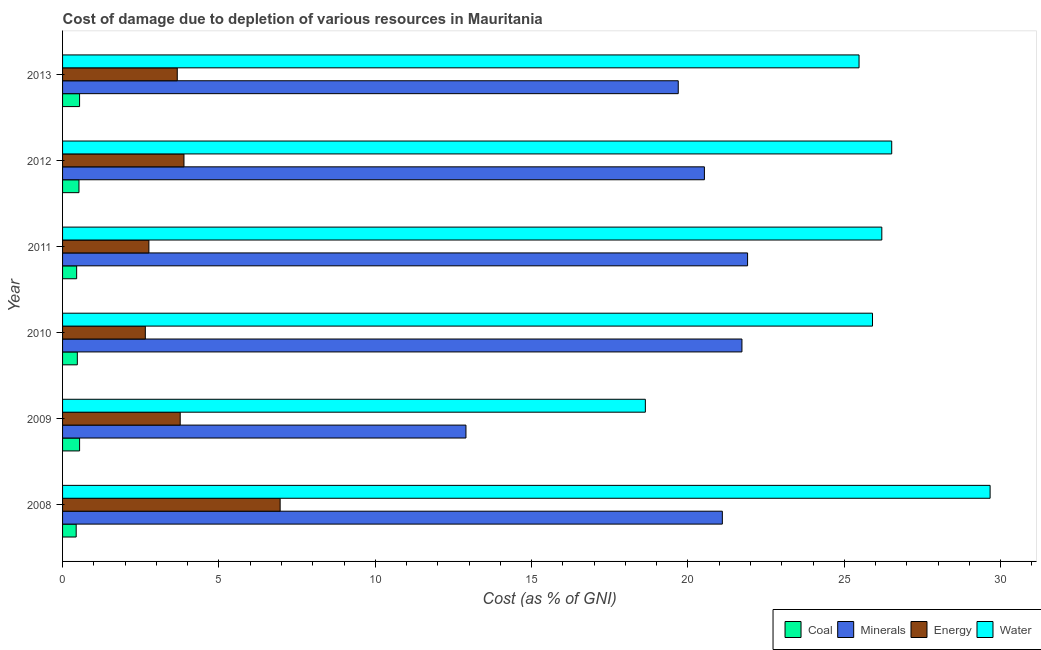How many different coloured bars are there?
Your answer should be very brief. 4. In how many cases, is the number of bars for a given year not equal to the number of legend labels?
Keep it short and to the point. 0. What is the cost of damage due to depletion of water in 2008?
Your answer should be very brief. 29.66. Across all years, what is the maximum cost of damage due to depletion of coal?
Provide a succinct answer. 0.54. Across all years, what is the minimum cost of damage due to depletion of coal?
Provide a succinct answer. 0.44. What is the total cost of damage due to depletion of coal in the graph?
Your answer should be compact. 2.97. What is the difference between the cost of damage due to depletion of water in 2008 and that in 2013?
Offer a very short reply. 4.19. What is the difference between the cost of damage due to depletion of energy in 2010 and the cost of damage due to depletion of minerals in 2011?
Offer a very short reply. -19.26. What is the average cost of damage due to depletion of water per year?
Offer a terse response. 25.4. In the year 2008, what is the difference between the cost of damage due to depletion of coal and cost of damage due to depletion of minerals?
Your answer should be very brief. -20.66. In how many years, is the cost of damage due to depletion of water greater than 12 %?
Ensure brevity in your answer.  6. What is the ratio of the cost of damage due to depletion of energy in 2009 to that in 2013?
Your answer should be compact. 1.03. Is the cost of damage due to depletion of energy in 2010 less than that in 2012?
Your answer should be compact. Yes. Is the difference between the cost of damage due to depletion of water in 2012 and 2013 greater than the difference between the cost of damage due to depletion of energy in 2012 and 2013?
Offer a terse response. Yes. What is the difference between the highest and the second highest cost of damage due to depletion of coal?
Your response must be concise. 0. What is the difference between the highest and the lowest cost of damage due to depletion of water?
Provide a short and direct response. 11.02. In how many years, is the cost of damage due to depletion of water greater than the average cost of damage due to depletion of water taken over all years?
Your answer should be very brief. 5. What does the 1st bar from the top in 2012 represents?
Your response must be concise. Water. What does the 1st bar from the bottom in 2013 represents?
Give a very brief answer. Coal. Are all the bars in the graph horizontal?
Provide a short and direct response. Yes. How many years are there in the graph?
Your answer should be very brief. 6. What is the difference between two consecutive major ticks on the X-axis?
Offer a very short reply. 5. Does the graph contain any zero values?
Your response must be concise. No. Where does the legend appear in the graph?
Your answer should be very brief. Bottom right. How many legend labels are there?
Your response must be concise. 4. What is the title of the graph?
Your answer should be very brief. Cost of damage due to depletion of various resources in Mauritania . Does "Social Assistance" appear as one of the legend labels in the graph?
Keep it short and to the point. No. What is the label or title of the X-axis?
Ensure brevity in your answer.  Cost (as % of GNI). What is the Cost (as % of GNI) of Coal in 2008?
Your answer should be compact. 0.44. What is the Cost (as % of GNI) of Minerals in 2008?
Your answer should be very brief. 21.1. What is the Cost (as % of GNI) of Energy in 2008?
Offer a terse response. 6.96. What is the Cost (as % of GNI) of Water in 2008?
Provide a succinct answer. 29.66. What is the Cost (as % of GNI) in Coal in 2009?
Ensure brevity in your answer.  0.54. What is the Cost (as % of GNI) of Minerals in 2009?
Your response must be concise. 12.9. What is the Cost (as % of GNI) in Energy in 2009?
Offer a terse response. 3.76. What is the Cost (as % of GNI) of Water in 2009?
Keep it short and to the point. 18.64. What is the Cost (as % of GNI) of Coal in 2010?
Provide a short and direct response. 0.47. What is the Cost (as % of GNI) of Minerals in 2010?
Give a very brief answer. 21.73. What is the Cost (as % of GNI) in Energy in 2010?
Give a very brief answer. 2.65. What is the Cost (as % of GNI) of Water in 2010?
Your answer should be compact. 25.9. What is the Cost (as % of GNI) of Coal in 2011?
Provide a succinct answer. 0.45. What is the Cost (as % of GNI) of Minerals in 2011?
Make the answer very short. 21.91. What is the Cost (as % of GNI) of Energy in 2011?
Keep it short and to the point. 2.76. What is the Cost (as % of GNI) in Water in 2011?
Keep it short and to the point. 26.2. What is the Cost (as % of GNI) in Coal in 2012?
Your response must be concise. 0.52. What is the Cost (as % of GNI) of Minerals in 2012?
Offer a terse response. 20.53. What is the Cost (as % of GNI) of Energy in 2012?
Give a very brief answer. 3.88. What is the Cost (as % of GNI) in Water in 2012?
Your response must be concise. 26.52. What is the Cost (as % of GNI) in Coal in 2013?
Your answer should be very brief. 0.54. What is the Cost (as % of GNI) of Minerals in 2013?
Keep it short and to the point. 19.69. What is the Cost (as % of GNI) in Energy in 2013?
Offer a very short reply. 3.67. What is the Cost (as % of GNI) in Water in 2013?
Give a very brief answer. 25.47. Across all years, what is the maximum Cost (as % of GNI) in Coal?
Your response must be concise. 0.54. Across all years, what is the maximum Cost (as % of GNI) of Minerals?
Your answer should be compact. 21.91. Across all years, what is the maximum Cost (as % of GNI) in Energy?
Provide a succinct answer. 6.96. Across all years, what is the maximum Cost (as % of GNI) in Water?
Offer a terse response. 29.66. Across all years, what is the minimum Cost (as % of GNI) of Coal?
Your response must be concise. 0.44. Across all years, what is the minimum Cost (as % of GNI) in Minerals?
Provide a succinct answer. 12.9. Across all years, what is the minimum Cost (as % of GNI) of Energy?
Your answer should be very brief. 2.65. Across all years, what is the minimum Cost (as % of GNI) in Water?
Give a very brief answer. 18.64. What is the total Cost (as % of GNI) in Coal in the graph?
Offer a very short reply. 2.97. What is the total Cost (as % of GNI) of Minerals in the graph?
Ensure brevity in your answer.  117.84. What is the total Cost (as % of GNI) in Energy in the graph?
Give a very brief answer. 23.68. What is the total Cost (as % of GNI) in Water in the graph?
Offer a terse response. 152.38. What is the difference between the Cost (as % of GNI) in Coal in 2008 and that in 2009?
Make the answer very short. -0.11. What is the difference between the Cost (as % of GNI) in Minerals in 2008 and that in 2009?
Give a very brief answer. 8.2. What is the difference between the Cost (as % of GNI) in Energy in 2008 and that in 2009?
Give a very brief answer. 3.2. What is the difference between the Cost (as % of GNI) of Water in 2008 and that in 2009?
Your response must be concise. 11.02. What is the difference between the Cost (as % of GNI) of Coal in 2008 and that in 2010?
Keep it short and to the point. -0.04. What is the difference between the Cost (as % of GNI) of Minerals in 2008 and that in 2010?
Give a very brief answer. -0.63. What is the difference between the Cost (as % of GNI) in Energy in 2008 and that in 2010?
Your answer should be compact. 4.31. What is the difference between the Cost (as % of GNI) of Water in 2008 and that in 2010?
Your response must be concise. 3.76. What is the difference between the Cost (as % of GNI) of Coal in 2008 and that in 2011?
Keep it short and to the point. -0.02. What is the difference between the Cost (as % of GNI) in Minerals in 2008 and that in 2011?
Your answer should be very brief. -0.81. What is the difference between the Cost (as % of GNI) of Energy in 2008 and that in 2011?
Offer a terse response. 4.2. What is the difference between the Cost (as % of GNI) in Water in 2008 and that in 2011?
Give a very brief answer. 3.46. What is the difference between the Cost (as % of GNI) in Coal in 2008 and that in 2012?
Your answer should be very brief. -0.09. What is the difference between the Cost (as % of GNI) of Minerals in 2008 and that in 2012?
Your answer should be very brief. 0.57. What is the difference between the Cost (as % of GNI) in Energy in 2008 and that in 2012?
Your answer should be very brief. 3.08. What is the difference between the Cost (as % of GNI) of Water in 2008 and that in 2012?
Give a very brief answer. 3.15. What is the difference between the Cost (as % of GNI) in Coal in 2008 and that in 2013?
Offer a very short reply. -0.11. What is the difference between the Cost (as % of GNI) of Minerals in 2008 and that in 2013?
Make the answer very short. 1.41. What is the difference between the Cost (as % of GNI) in Energy in 2008 and that in 2013?
Provide a succinct answer. 3.29. What is the difference between the Cost (as % of GNI) in Water in 2008 and that in 2013?
Provide a short and direct response. 4.19. What is the difference between the Cost (as % of GNI) in Coal in 2009 and that in 2010?
Ensure brevity in your answer.  0.07. What is the difference between the Cost (as % of GNI) in Minerals in 2009 and that in 2010?
Provide a short and direct response. -8.83. What is the difference between the Cost (as % of GNI) in Energy in 2009 and that in 2010?
Make the answer very short. 1.12. What is the difference between the Cost (as % of GNI) of Water in 2009 and that in 2010?
Offer a terse response. -7.26. What is the difference between the Cost (as % of GNI) of Coal in 2009 and that in 2011?
Your response must be concise. 0.09. What is the difference between the Cost (as % of GNI) of Minerals in 2009 and that in 2011?
Make the answer very short. -9.01. What is the difference between the Cost (as % of GNI) of Water in 2009 and that in 2011?
Offer a terse response. -7.56. What is the difference between the Cost (as % of GNI) in Coal in 2009 and that in 2012?
Provide a succinct answer. 0.02. What is the difference between the Cost (as % of GNI) of Minerals in 2009 and that in 2012?
Provide a short and direct response. -7.63. What is the difference between the Cost (as % of GNI) of Energy in 2009 and that in 2012?
Your answer should be very brief. -0.12. What is the difference between the Cost (as % of GNI) in Water in 2009 and that in 2012?
Make the answer very short. -7.88. What is the difference between the Cost (as % of GNI) of Coal in 2009 and that in 2013?
Ensure brevity in your answer.  0. What is the difference between the Cost (as % of GNI) in Minerals in 2009 and that in 2013?
Offer a terse response. -6.79. What is the difference between the Cost (as % of GNI) of Energy in 2009 and that in 2013?
Give a very brief answer. 0.09. What is the difference between the Cost (as % of GNI) of Water in 2009 and that in 2013?
Ensure brevity in your answer.  -6.83. What is the difference between the Cost (as % of GNI) in Coal in 2010 and that in 2011?
Your answer should be compact. 0.02. What is the difference between the Cost (as % of GNI) in Minerals in 2010 and that in 2011?
Your response must be concise. -0.18. What is the difference between the Cost (as % of GNI) of Energy in 2010 and that in 2011?
Make the answer very short. -0.11. What is the difference between the Cost (as % of GNI) in Water in 2010 and that in 2011?
Your response must be concise. -0.3. What is the difference between the Cost (as % of GNI) in Coal in 2010 and that in 2012?
Ensure brevity in your answer.  -0.05. What is the difference between the Cost (as % of GNI) of Energy in 2010 and that in 2012?
Keep it short and to the point. -1.24. What is the difference between the Cost (as % of GNI) of Water in 2010 and that in 2012?
Make the answer very short. -0.61. What is the difference between the Cost (as % of GNI) in Coal in 2010 and that in 2013?
Your answer should be very brief. -0.07. What is the difference between the Cost (as % of GNI) in Minerals in 2010 and that in 2013?
Make the answer very short. 2.04. What is the difference between the Cost (as % of GNI) of Energy in 2010 and that in 2013?
Offer a terse response. -1.02. What is the difference between the Cost (as % of GNI) in Water in 2010 and that in 2013?
Offer a terse response. 0.43. What is the difference between the Cost (as % of GNI) of Coal in 2011 and that in 2012?
Offer a terse response. -0.07. What is the difference between the Cost (as % of GNI) in Minerals in 2011 and that in 2012?
Make the answer very short. 1.38. What is the difference between the Cost (as % of GNI) in Energy in 2011 and that in 2012?
Your answer should be very brief. -1.12. What is the difference between the Cost (as % of GNI) in Water in 2011 and that in 2012?
Offer a very short reply. -0.32. What is the difference between the Cost (as % of GNI) in Coal in 2011 and that in 2013?
Your answer should be very brief. -0.09. What is the difference between the Cost (as % of GNI) in Minerals in 2011 and that in 2013?
Offer a very short reply. 2.22. What is the difference between the Cost (as % of GNI) in Energy in 2011 and that in 2013?
Give a very brief answer. -0.91. What is the difference between the Cost (as % of GNI) in Water in 2011 and that in 2013?
Provide a succinct answer. 0.73. What is the difference between the Cost (as % of GNI) of Coal in 2012 and that in 2013?
Your answer should be very brief. -0.02. What is the difference between the Cost (as % of GNI) of Minerals in 2012 and that in 2013?
Your answer should be very brief. 0.84. What is the difference between the Cost (as % of GNI) in Energy in 2012 and that in 2013?
Make the answer very short. 0.21. What is the difference between the Cost (as % of GNI) of Water in 2012 and that in 2013?
Ensure brevity in your answer.  1.04. What is the difference between the Cost (as % of GNI) in Coal in 2008 and the Cost (as % of GNI) in Minerals in 2009?
Keep it short and to the point. -12.46. What is the difference between the Cost (as % of GNI) in Coal in 2008 and the Cost (as % of GNI) in Energy in 2009?
Your answer should be compact. -3.33. What is the difference between the Cost (as % of GNI) of Coal in 2008 and the Cost (as % of GNI) of Water in 2009?
Provide a succinct answer. -18.2. What is the difference between the Cost (as % of GNI) in Minerals in 2008 and the Cost (as % of GNI) in Energy in 2009?
Provide a succinct answer. 17.34. What is the difference between the Cost (as % of GNI) in Minerals in 2008 and the Cost (as % of GNI) in Water in 2009?
Your answer should be compact. 2.46. What is the difference between the Cost (as % of GNI) of Energy in 2008 and the Cost (as % of GNI) of Water in 2009?
Your answer should be very brief. -11.68. What is the difference between the Cost (as % of GNI) of Coal in 2008 and the Cost (as % of GNI) of Minerals in 2010?
Your response must be concise. -21.29. What is the difference between the Cost (as % of GNI) of Coal in 2008 and the Cost (as % of GNI) of Energy in 2010?
Give a very brief answer. -2.21. What is the difference between the Cost (as % of GNI) of Coal in 2008 and the Cost (as % of GNI) of Water in 2010?
Provide a succinct answer. -25.47. What is the difference between the Cost (as % of GNI) in Minerals in 2008 and the Cost (as % of GNI) in Energy in 2010?
Keep it short and to the point. 18.45. What is the difference between the Cost (as % of GNI) of Minerals in 2008 and the Cost (as % of GNI) of Water in 2010?
Ensure brevity in your answer.  -4.8. What is the difference between the Cost (as % of GNI) in Energy in 2008 and the Cost (as % of GNI) in Water in 2010?
Offer a terse response. -18.94. What is the difference between the Cost (as % of GNI) of Coal in 2008 and the Cost (as % of GNI) of Minerals in 2011?
Offer a terse response. -21.47. What is the difference between the Cost (as % of GNI) in Coal in 2008 and the Cost (as % of GNI) in Energy in 2011?
Provide a succinct answer. -2.33. What is the difference between the Cost (as % of GNI) of Coal in 2008 and the Cost (as % of GNI) of Water in 2011?
Provide a short and direct response. -25.76. What is the difference between the Cost (as % of GNI) in Minerals in 2008 and the Cost (as % of GNI) in Energy in 2011?
Provide a short and direct response. 18.34. What is the difference between the Cost (as % of GNI) of Minerals in 2008 and the Cost (as % of GNI) of Water in 2011?
Offer a terse response. -5.1. What is the difference between the Cost (as % of GNI) in Energy in 2008 and the Cost (as % of GNI) in Water in 2011?
Keep it short and to the point. -19.24. What is the difference between the Cost (as % of GNI) of Coal in 2008 and the Cost (as % of GNI) of Minerals in 2012?
Provide a succinct answer. -20.09. What is the difference between the Cost (as % of GNI) of Coal in 2008 and the Cost (as % of GNI) of Energy in 2012?
Keep it short and to the point. -3.45. What is the difference between the Cost (as % of GNI) in Coal in 2008 and the Cost (as % of GNI) in Water in 2012?
Make the answer very short. -26.08. What is the difference between the Cost (as % of GNI) in Minerals in 2008 and the Cost (as % of GNI) in Energy in 2012?
Your answer should be very brief. 17.22. What is the difference between the Cost (as % of GNI) of Minerals in 2008 and the Cost (as % of GNI) of Water in 2012?
Make the answer very short. -5.42. What is the difference between the Cost (as % of GNI) in Energy in 2008 and the Cost (as % of GNI) in Water in 2012?
Give a very brief answer. -19.56. What is the difference between the Cost (as % of GNI) in Coal in 2008 and the Cost (as % of GNI) in Minerals in 2013?
Your response must be concise. -19.25. What is the difference between the Cost (as % of GNI) in Coal in 2008 and the Cost (as % of GNI) in Energy in 2013?
Provide a short and direct response. -3.23. What is the difference between the Cost (as % of GNI) in Coal in 2008 and the Cost (as % of GNI) in Water in 2013?
Keep it short and to the point. -25.03. What is the difference between the Cost (as % of GNI) in Minerals in 2008 and the Cost (as % of GNI) in Energy in 2013?
Your answer should be compact. 17.43. What is the difference between the Cost (as % of GNI) in Minerals in 2008 and the Cost (as % of GNI) in Water in 2013?
Provide a succinct answer. -4.37. What is the difference between the Cost (as % of GNI) of Energy in 2008 and the Cost (as % of GNI) of Water in 2013?
Keep it short and to the point. -18.51. What is the difference between the Cost (as % of GNI) of Coal in 2009 and the Cost (as % of GNI) of Minerals in 2010?
Keep it short and to the point. -21.18. What is the difference between the Cost (as % of GNI) in Coal in 2009 and the Cost (as % of GNI) in Energy in 2010?
Your answer should be very brief. -2.1. What is the difference between the Cost (as % of GNI) in Coal in 2009 and the Cost (as % of GNI) in Water in 2010?
Offer a terse response. -25.36. What is the difference between the Cost (as % of GNI) of Minerals in 2009 and the Cost (as % of GNI) of Energy in 2010?
Ensure brevity in your answer.  10.25. What is the difference between the Cost (as % of GNI) in Minerals in 2009 and the Cost (as % of GNI) in Water in 2010?
Offer a terse response. -13. What is the difference between the Cost (as % of GNI) in Energy in 2009 and the Cost (as % of GNI) in Water in 2010?
Your response must be concise. -22.14. What is the difference between the Cost (as % of GNI) in Coal in 2009 and the Cost (as % of GNI) in Minerals in 2011?
Offer a very short reply. -21.36. What is the difference between the Cost (as % of GNI) of Coal in 2009 and the Cost (as % of GNI) of Energy in 2011?
Provide a short and direct response. -2.22. What is the difference between the Cost (as % of GNI) in Coal in 2009 and the Cost (as % of GNI) in Water in 2011?
Make the answer very short. -25.65. What is the difference between the Cost (as % of GNI) in Minerals in 2009 and the Cost (as % of GNI) in Energy in 2011?
Your response must be concise. 10.14. What is the difference between the Cost (as % of GNI) of Minerals in 2009 and the Cost (as % of GNI) of Water in 2011?
Ensure brevity in your answer.  -13.3. What is the difference between the Cost (as % of GNI) of Energy in 2009 and the Cost (as % of GNI) of Water in 2011?
Ensure brevity in your answer.  -22.44. What is the difference between the Cost (as % of GNI) in Coal in 2009 and the Cost (as % of GNI) in Minerals in 2012?
Give a very brief answer. -19.98. What is the difference between the Cost (as % of GNI) of Coal in 2009 and the Cost (as % of GNI) of Energy in 2012?
Your response must be concise. -3.34. What is the difference between the Cost (as % of GNI) of Coal in 2009 and the Cost (as % of GNI) of Water in 2012?
Provide a succinct answer. -25.97. What is the difference between the Cost (as % of GNI) of Minerals in 2009 and the Cost (as % of GNI) of Energy in 2012?
Offer a very short reply. 9.02. What is the difference between the Cost (as % of GNI) of Minerals in 2009 and the Cost (as % of GNI) of Water in 2012?
Your response must be concise. -13.62. What is the difference between the Cost (as % of GNI) in Energy in 2009 and the Cost (as % of GNI) in Water in 2012?
Provide a succinct answer. -22.75. What is the difference between the Cost (as % of GNI) of Coal in 2009 and the Cost (as % of GNI) of Minerals in 2013?
Offer a terse response. -19.14. What is the difference between the Cost (as % of GNI) of Coal in 2009 and the Cost (as % of GNI) of Energy in 2013?
Your answer should be compact. -3.12. What is the difference between the Cost (as % of GNI) in Coal in 2009 and the Cost (as % of GNI) in Water in 2013?
Keep it short and to the point. -24.93. What is the difference between the Cost (as % of GNI) in Minerals in 2009 and the Cost (as % of GNI) in Energy in 2013?
Give a very brief answer. 9.23. What is the difference between the Cost (as % of GNI) in Minerals in 2009 and the Cost (as % of GNI) in Water in 2013?
Provide a short and direct response. -12.57. What is the difference between the Cost (as % of GNI) in Energy in 2009 and the Cost (as % of GNI) in Water in 2013?
Your answer should be very brief. -21.71. What is the difference between the Cost (as % of GNI) of Coal in 2010 and the Cost (as % of GNI) of Minerals in 2011?
Provide a succinct answer. -21.43. What is the difference between the Cost (as % of GNI) in Coal in 2010 and the Cost (as % of GNI) in Energy in 2011?
Your response must be concise. -2.29. What is the difference between the Cost (as % of GNI) of Coal in 2010 and the Cost (as % of GNI) of Water in 2011?
Your answer should be compact. -25.73. What is the difference between the Cost (as % of GNI) of Minerals in 2010 and the Cost (as % of GNI) of Energy in 2011?
Your response must be concise. 18.96. What is the difference between the Cost (as % of GNI) of Minerals in 2010 and the Cost (as % of GNI) of Water in 2011?
Your answer should be compact. -4.47. What is the difference between the Cost (as % of GNI) of Energy in 2010 and the Cost (as % of GNI) of Water in 2011?
Your response must be concise. -23.55. What is the difference between the Cost (as % of GNI) in Coal in 2010 and the Cost (as % of GNI) in Minerals in 2012?
Offer a very short reply. -20.05. What is the difference between the Cost (as % of GNI) in Coal in 2010 and the Cost (as % of GNI) in Energy in 2012?
Give a very brief answer. -3.41. What is the difference between the Cost (as % of GNI) in Coal in 2010 and the Cost (as % of GNI) in Water in 2012?
Keep it short and to the point. -26.04. What is the difference between the Cost (as % of GNI) in Minerals in 2010 and the Cost (as % of GNI) in Energy in 2012?
Provide a short and direct response. 17.84. What is the difference between the Cost (as % of GNI) of Minerals in 2010 and the Cost (as % of GNI) of Water in 2012?
Your response must be concise. -4.79. What is the difference between the Cost (as % of GNI) in Energy in 2010 and the Cost (as % of GNI) in Water in 2012?
Ensure brevity in your answer.  -23.87. What is the difference between the Cost (as % of GNI) in Coal in 2010 and the Cost (as % of GNI) in Minerals in 2013?
Give a very brief answer. -19.22. What is the difference between the Cost (as % of GNI) in Coal in 2010 and the Cost (as % of GNI) in Energy in 2013?
Your response must be concise. -3.2. What is the difference between the Cost (as % of GNI) of Coal in 2010 and the Cost (as % of GNI) of Water in 2013?
Provide a succinct answer. -25. What is the difference between the Cost (as % of GNI) in Minerals in 2010 and the Cost (as % of GNI) in Energy in 2013?
Provide a short and direct response. 18.06. What is the difference between the Cost (as % of GNI) in Minerals in 2010 and the Cost (as % of GNI) in Water in 2013?
Provide a succinct answer. -3.75. What is the difference between the Cost (as % of GNI) in Energy in 2010 and the Cost (as % of GNI) in Water in 2013?
Offer a terse response. -22.82. What is the difference between the Cost (as % of GNI) in Coal in 2011 and the Cost (as % of GNI) in Minerals in 2012?
Provide a succinct answer. -20.07. What is the difference between the Cost (as % of GNI) of Coal in 2011 and the Cost (as % of GNI) of Energy in 2012?
Ensure brevity in your answer.  -3.43. What is the difference between the Cost (as % of GNI) in Coal in 2011 and the Cost (as % of GNI) in Water in 2012?
Provide a succinct answer. -26.06. What is the difference between the Cost (as % of GNI) of Minerals in 2011 and the Cost (as % of GNI) of Energy in 2012?
Ensure brevity in your answer.  18.02. What is the difference between the Cost (as % of GNI) of Minerals in 2011 and the Cost (as % of GNI) of Water in 2012?
Provide a short and direct response. -4.61. What is the difference between the Cost (as % of GNI) in Energy in 2011 and the Cost (as % of GNI) in Water in 2012?
Provide a short and direct response. -23.75. What is the difference between the Cost (as % of GNI) of Coal in 2011 and the Cost (as % of GNI) of Minerals in 2013?
Provide a succinct answer. -19.24. What is the difference between the Cost (as % of GNI) in Coal in 2011 and the Cost (as % of GNI) in Energy in 2013?
Your answer should be very brief. -3.22. What is the difference between the Cost (as % of GNI) in Coal in 2011 and the Cost (as % of GNI) in Water in 2013?
Offer a very short reply. -25.02. What is the difference between the Cost (as % of GNI) of Minerals in 2011 and the Cost (as % of GNI) of Energy in 2013?
Your answer should be very brief. 18.24. What is the difference between the Cost (as % of GNI) of Minerals in 2011 and the Cost (as % of GNI) of Water in 2013?
Keep it short and to the point. -3.56. What is the difference between the Cost (as % of GNI) of Energy in 2011 and the Cost (as % of GNI) of Water in 2013?
Provide a short and direct response. -22.71. What is the difference between the Cost (as % of GNI) in Coal in 2012 and the Cost (as % of GNI) in Minerals in 2013?
Your answer should be very brief. -19.16. What is the difference between the Cost (as % of GNI) of Coal in 2012 and the Cost (as % of GNI) of Energy in 2013?
Ensure brevity in your answer.  -3.14. What is the difference between the Cost (as % of GNI) in Coal in 2012 and the Cost (as % of GNI) in Water in 2013?
Make the answer very short. -24.95. What is the difference between the Cost (as % of GNI) of Minerals in 2012 and the Cost (as % of GNI) of Energy in 2013?
Provide a short and direct response. 16.86. What is the difference between the Cost (as % of GNI) of Minerals in 2012 and the Cost (as % of GNI) of Water in 2013?
Provide a succinct answer. -4.95. What is the difference between the Cost (as % of GNI) of Energy in 2012 and the Cost (as % of GNI) of Water in 2013?
Provide a short and direct response. -21.59. What is the average Cost (as % of GNI) of Coal per year?
Ensure brevity in your answer.  0.5. What is the average Cost (as % of GNI) of Minerals per year?
Provide a succinct answer. 19.64. What is the average Cost (as % of GNI) of Energy per year?
Keep it short and to the point. 3.95. What is the average Cost (as % of GNI) in Water per year?
Your answer should be very brief. 25.4. In the year 2008, what is the difference between the Cost (as % of GNI) of Coal and Cost (as % of GNI) of Minerals?
Provide a short and direct response. -20.66. In the year 2008, what is the difference between the Cost (as % of GNI) in Coal and Cost (as % of GNI) in Energy?
Provide a short and direct response. -6.52. In the year 2008, what is the difference between the Cost (as % of GNI) of Coal and Cost (as % of GNI) of Water?
Your response must be concise. -29.23. In the year 2008, what is the difference between the Cost (as % of GNI) in Minerals and Cost (as % of GNI) in Energy?
Offer a terse response. 14.14. In the year 2008, what is the difference between the Cost (as % of GNI) of Minerals and Cost (as % of GNI) of Water?
Provide a short and direct response. -8.56. In the year 2008, what is the difference between the Cost (as % of GNI) of Energy and Cost (as % of GNI) of Water?
Offer a very short reply. -22.7. In the year 2009, what is the difference between the Cost (as % of GNI) of Coal and Cost (as % of GNI) of Minerals?
Ensure brevity in your answer.  -12.36. In the year 2009, what is the difference between the Cost (as % of GNI) in Coal and Cost (as % of GNI) in Energy?
Offer a very short reply. -3.22. In the year 2009, what is the difference between the Cost (as % of GNI) of Coal and Cost (as % of GNI) of Water?
Keep it short and to the point. -18.09. In the year 2009, what is the difference between the Cost (as % of GNI) in Minerals and Cost (as % of GNI) in Energy?
Your answer should be compact. 9.14. In the year 2009, what is the difference between the Cost (as % of GNI) in Minerals and Cost (as % of GNI) in Water?
Your answer should be very brief. -5.74. In the year 2009, what is the difference between the Cost (as % of GNI) in Energy and Cost (as % of GNI) in Water?
Offer a terse response. -14.88. In the year 2010, what is the difference between the Cost (as % of GNI) in Coal and Cost (as % of GNI) in Minerals?
Offer a very short reply. -21.25. In the year 2010, what is the difference between the Cost (as % of GNI) in Coal and Cost (as % of GNI) in Energy?
Your response must be concise. -2.17. In the year 2010, what is the difference between the Cost (as % of GNI) of Coal and Cost (as % of GNI) of Water?
Your answer should be compact. -25.43. In the year 2010, what is the difference between the Cost (as % of GNI) of Minerals and Cost (as % of GNI) of Energy?
Your answer should be compact. 19.08. In the year 2010, what is the difference between the Cost (as % of GNI) in Minerals and Cost (as % of GNI) in Water?
Give a very brief answer. -4.18. In the year 2010, what is the difference between the Cost (as % of GNI) of Energy and Cost (as % of GNI) of Water?
Give a very brief answer. -23.25. In the year 2011, what is the difference between the Cost (as % of GNI) in Coal and Cost (as % of GNI) in Minerals?
Your answer should be very brief. -21.46. In the year 2011, what is the difference between the Cost (as % of GNI) in Coal and Cost (as % of GNI) in Energy?
Make the answer very short. -2.31. In the year 2011, what is the difference between the Cost (as % of GNI) of Coal and Cost (as % of GNI) of Water?
Make the answer very short. -25.75. In the year 2011, what is the difference between the Cost (as % of GNI) of Minerals and Cost (as % of GNI) of Energy?
Provide a succinct answer. 19.15. In the year 2011, what is the difference between the Cost (as % of GNI) in Minerals and Cost (as % of GNI) in Water?
Ensure brevity in your answer.  -4.29. In the year 2011, what is the difference between the Cost (as % of GNI) of Energy and Cost (as % of GNI) of Water?
Offer a terse response. -23.44. In the year 2012, what is the difference between the Cost (as % of GNI) in Coal and Cost (as % of GNI) in Minerals?
Keep it short and to the point. -20. In the year 2012, what is the difference between the Cost (as % of GNI) in Coal and Cost (as % of GNI) in Energy?
Make the answer very short. -3.36. In the year 2012, what is the difference between the Cost (as % of GNI) of Coal and Cost (as % of GNI) of Water?
Keep it short and to the point. -25.99. In the year 2012, what is the difference between the Cost (as % of GNI) in Minerals and Cost (as % of GNI) in Energy?
Provide a succinct answer. 16.64. In the year 2012, what is the difference between the Cost (as % of GNI) of Minerals and Cost (as % of GNI) of Water?
Offer a very short reply. -5.99. In the year 2012, what is the difference between the Cost (as % of GNI) of Energy and Cost (as % of GNI) of Water?
Provide a short and direct response. -22.63. In the year 2013, what is the difference between the Cost (as % of GNI) in Coal and Cost (as % of GNI) in Minerals?
Offer a terse response. -19.14. In the year 2013, what is the difference between the Cost (as % of GNI) of Coal and Cost (as % of GNI) of Energy?
Offer a terse response. -3.12. In the year 2013, what is the difference between the Cost (as % of GNI) in Coal and Cost (as % of GNI) in Water?
Provide a short and direct response. -24.93. In the year 2013, what is the difference between the Cost (as % of GNI) in Minerals and Cost (as % of GNI) in Energy?
Provide a succinct answer. 16.02. In the year 2013, what is the difference between the Cost (as % of GNI) of Minerals and Cost (as % of GNI) of Water?
Make the answer very short. -5.78. In the year 2013, what is the difference between the Cost (as % of GNI) in Energy and Cost (as % of GNI) in Water?
Provide a succinct answer. -21.8. What is the ratio of the Cost (as % of GNI) in Coal in 2008 to that in 2009?
Provide a short and direct response. 0.8. What is the ratio of the Cost (as % of GNI) in Minerals in 2008 to that in 2009?
Keep it short and to the point. 1.64. What is the ratio of the Cost (as % of GNI) in Energy in 2008 to that in 2009?
Give a very brief answer. 1.85. What is the ratio of the Cost (as % of GNI) in Water in 2008 to that in 2009?
Your answer should be compact. 1.59. What is the ratio of the Cost (as % of GNI) in Coal in 2008 to that in 2010?
Your answer should be compact. 0.92. What is the ratio of the Cost (as % of GNI) of Minerals in 2008 to that in 2010?
Offer a terse response. 0.97. What is the ratio of the Cost (as % of GNI) in Energy in 2008 to that in 2010?
Provide a succinct answer. 2.63. What is the ratio of the Cost (as % of GNI) in Water in 2008 to that in 2010?
Make the answer very short. 1.15. What is the ratio of the Cost (as % of GNI) of Coal in 2008 to that in 2011?
Your answer should be very brief. 0.97. What is the ratio of the Cost (as % of GNI) in Minerals in 2008 to that in 2011?
Your answer should be compact. 0.96. What is the ratio of the Cost (as % of GNI) in Energy in 2008 to that in 2011?
Keep it short and to the point. 2.52. What is the ratio of the Cost (as % of GNI) of Water in 2008 to that in 2011?
Keep it short and to the point. 1.13. What is the ratio of the Cost (as % of GNI) of Coal in 2008 to that in 2012?
Your answer should be very brief. 0.83. What is the ratio of the Cost (as % of GNI) in Minerals in 2008 to that in 2012?
Your response must be concise. 1.03. What is the ratio of the Cost (as % of GNI) of Energy in 2008 to that in 2012?
Provide a succinct answer. 1.79. What is the ratio of the Cost (as % of GNI) in Water in 2008 to that in 2012?
Provide a short and direct response. 1.12. What is the ratio of the Cost (as % of GNI) in Coal in 2008 to that in 2013?
Offer a terse response. 0.8. What is the ratio of the Cost (as % of GNI) in Minerals in 2008 to that in 2013?
Make the answer very short. 1.07. What is the ratio of the Cost (as % of GNI) in Energy in 2008 to that in 2013?
Provide a short and direct response. 1.9. What is the ratio of the Cost (as % of GNI) of Water in 2008 to that in 2013?
Your response must be concise. 1.16. What is the ratio of the Cost (as % of GNI) in Coal in 2009 to that in 2010?
Offer a terse response. 1.15. What is the ratio of the Cost (as % of GNI) in Minerals in 2009 to that in 2010?
Ensure brevity in your answer.  0.59. What is the ratio of the Cost (as % of GNI) of Energy in 2009 to that in 2010?
Make the answer very short. 1.42. What is the ratio of the Cost (as % of GNI) in Water in 2009 to that in 2010?
Provide a short and direct response. 0.72. What is the ratio of the Cost (as % of GNI) in Coal in 2009 to that in 2011?
Make the answer very short. 1.21. What is the ratio of the Cost (as % of GNI) of Minerals in 2009 to that in 2011?
Provide a succinct answer. 0.59. What is the ratio of the Cost (as % of GNI) in Energy in 2009 to that in 2011?
Your answer should be compact. 1.36. What is the ratio of the Cost (as % of GNI) of Water in 2009 to that in 2011?
Your answer should be very brief. 0.71. What is the ratio of the Cost (as % of GNI) in Coal in 2009 to that in 2012?
Provide a short and direct response. 1.04. What is the ratio of the Cost (as % of GNI) in Minerals in 2009 to that in 2012?
Your answer should be compact. 0.63. What is the ratio of the Cost (as % of GNI) in Energy in 2009 to that in 2012?
Provide a short and direct response. 0.97. What is the ratio of the Cost (as % of GNI) of Water in 2009 to that in 2012?
Keep it short and to the point. 0.7. What is the ratio of the Cost (as % of GNI) in Minerals in 2009 to that in 2013?
Ensure brevity in your answer.  0.66. What is the ratio of the Cost (as % of GNI) of Energy in 2009 to that in 2013?
Offer a very short reply. 1.03. What is the ratio of the Cost (as % of GNI) of Water in 2009 to that in 2013?
Provide a short and direct response. 0.73. What is the ratio of the Cost (as % of GNI) of Coal in 2010 to that in 2011?
Provide a short and direct response. 1.05. What is the ratio of the Cost (as % of GNI) in Energy in 2010 to that in 2011?
Your response must be concise. 0.96. What is the ratio of the Cost (as % of GNI) of Coal in 2010 to that in 2012?
Provide a succinct answer. 0.9. What is the ratio of the Cost (as % of GNI) of Minerals in 2010 to that in 2012?
Give a very brief answer. 1.06. What is the ratio of the Cost (as % of GNI) in Energy in 2010 to that in 2012?
Offer a terse response. 0.68. What is the ratio of the Cost (as % of GNI) of Water in 2010 to that in 2012?
Offer a very short reply. 0.98. What is the ratio of the Cost (as % of GNI) of Coal in 2010 to that in 2013?
Your answer should be very brief. 0.87. What is the ratio of the Cost (as % of GNI) in Minerals in 2010 to that in 2013?
Offer a very short reply. 1.1. What is the ratio of the Cost (as % of GNI) of Energy in 2010 to that in 2013?
Offer a very short reply. 0.72. What is the ratio of the Cost (as % of GNI) in Water in 2010 to that in 2013?
Offer a terse response. 1.02. What is the ratio of the Cost (as % of GNI) of Coal in 2011 to that in 2012?
Your answer should be compact. 0.86. What is the ratio of the Cost (as % of GNI) in Minerals in 2011 to that in 2012?
Ensure brevity in your answer.  1.07. What is the ratio of the Cost (as % of GNI) of Energy in 2011 to that in 2012?
Provide a short and direct response. 0.71. What is the ratio of the Cost (as % of GNI) of Water in 2011 to that in 2012?
Make the answer very short. 0.99. What is the ratio of the Cost (as % of GNI) of Coal in 2011 to that in 2013?
Offer a very short reply. 0.83. What is the ratio of the Cost (as % of GNI) of Minerals in 2011 to that in 2013?
Provide a short and direct response. 1.11. What is the ratio of the Cost (as % of GNI) of Energy in 2011 to that in 2013?
Offer a very short reply. 0.75. What is the ratio of the Cost (as % of GNI) in Water in 2011 to that in 2013?
Provide a short and direct response. 1.03. What is the ratio of the Cost (as % of GNI) of Coal in 2012 to that in 2013?
Ensure brevity in your answer.  0.96. What is the ratio of the Cost (as % of GNI) in Minerals in 2012 to that in 2013?
Provide a short and direct response. 1.04. What is the ratio of the Cost (as % of GNI) in Energy in 2012 to that in 2013?
Your response must be concise. 1.06. What is the ratio of the Cost (as % of GNI) in Water in 2012 to that in 2013?
Keep it short and to the point. 1.04. What is the difference between the highest and the second highest Cost (as % of GNI) in Coal?
Give a very brief answer. 0. What is the difference between the highest and the second highest Cost (as % of GNI) in Minerals?
Offer a very short reply. 0.18. What is the difference between the highest and the second highest Cost (as % of GNI) in Energy?
Make the answer very short. 3.08. What is the difference between the highest and the second highest Cost (as % of GNI) of Water?
Make the answer very short. 3.15. What is the difference between the highest and the lowest Cost (as % of GNI) in Coal?
Offer a terse response. 0.11. What is the difference between the highest and the lowest Cost (as % of GNI) in Minerals?
Keep it short and to the point. 9.01. What is the difference between the highest and the lowest Cost (as % of GNI) of Energy?
Offer a very short reply. 4.31. What is the difference between the highest and the lowest Cost (as % of GNI) of Water?
Keep it short and to the point. 11.02. 